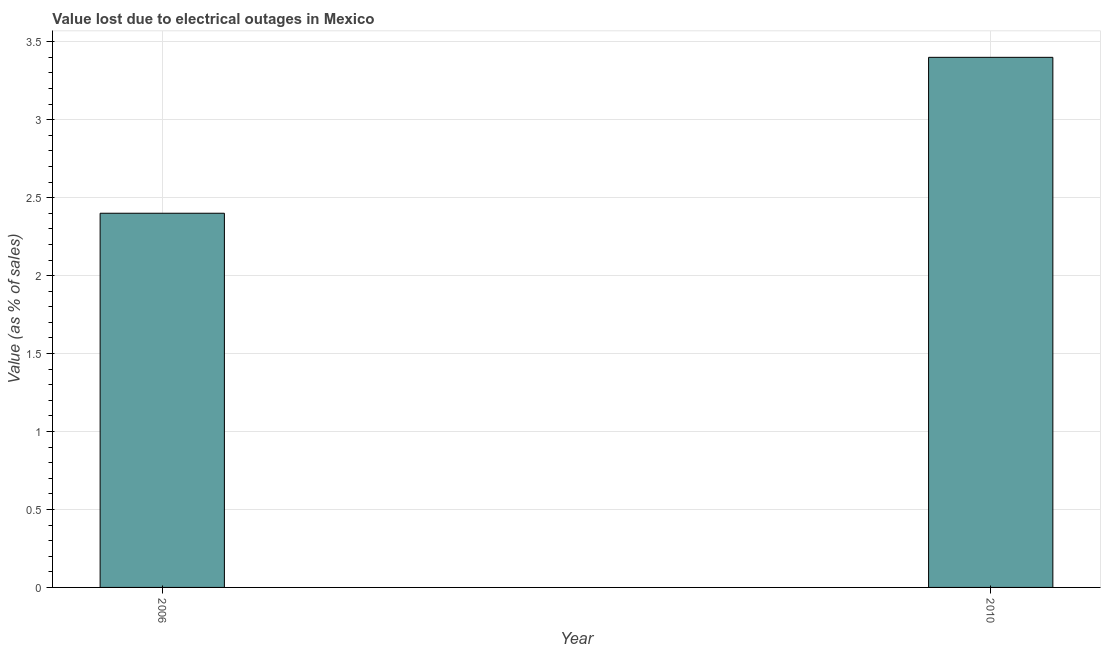Does the graph contain any zero values?
Make the answer very short. No. What is the title of the graph?
Offer a very short reply. Value lost due to electrical outages in Mexico. What is the label or title of the Y-axis?
Give a very brief answer. Value (as % of sales). In which year was the value lost due to electrical outages maximum?
Make the answer very short. 2010. What is the sum of the value lost due to electrical outages?
Ensure brevity in your answer.  5.8. What is the difference between the value lost due to electrical outages in 2006 and 2010?
Provide a succinct answer. -1. What is the average value lost due to electrical outages per year?
Make the answer very short. 2.9. What is the median value lost due to electrical outages?
Offer a terse response. 2.9. In how many years, is the value lost due to electrical outages greater than 2.4 %?
Provide a succinct answer. 1. What is the ratio of the value lost due to electrical outages in 2006 to that in 2010?
Provide a short and direct response. 0.71. How many bars are there?
Make the answer very short. 2. Are all the bars in the graph horizontal?
Ensure brevity in your answer.  No. How many years are there in the graph?
Your answer should be very brief. 2. What is the difference between two consecutive major ticks on the Y-axis?
Give a very brief answer. 0.5. Are the values on the major ticks of Y-axis written in scientific E-notation?
Offer a terse response. No. What is the difference between the Value (as % of sales) in 2006 and 2010?
Your answer should be very brief. -1. What is the ratio of the Value (as % of sales) in 2006 to that in 2010?
Provide a short and direct response. 0.71. 